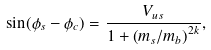<formula> <loc_0><loc_0><loc_500><loc_500>\sin ( \phi _ { s } - \phi _ { c } ) = \frac { V _ { u s } } { 1 + \left ( m _ { s } / m _ { b } \right ) ^ { 2 k } } ,</formula> 